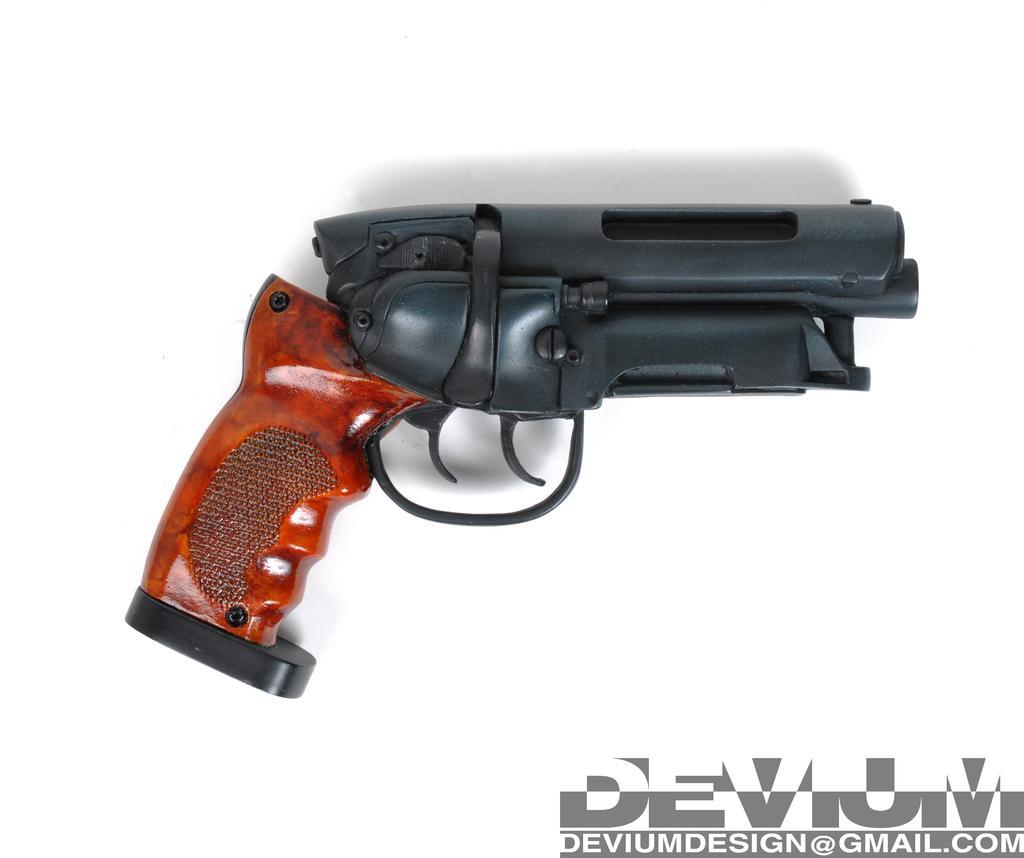Describe this image in one or two sentences. In this image I can see gun in black and brown color and background is in white color. 